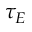<formula> <loc_0><loc_0><loc_500><loc_500>\tau _ { E }</formula> 